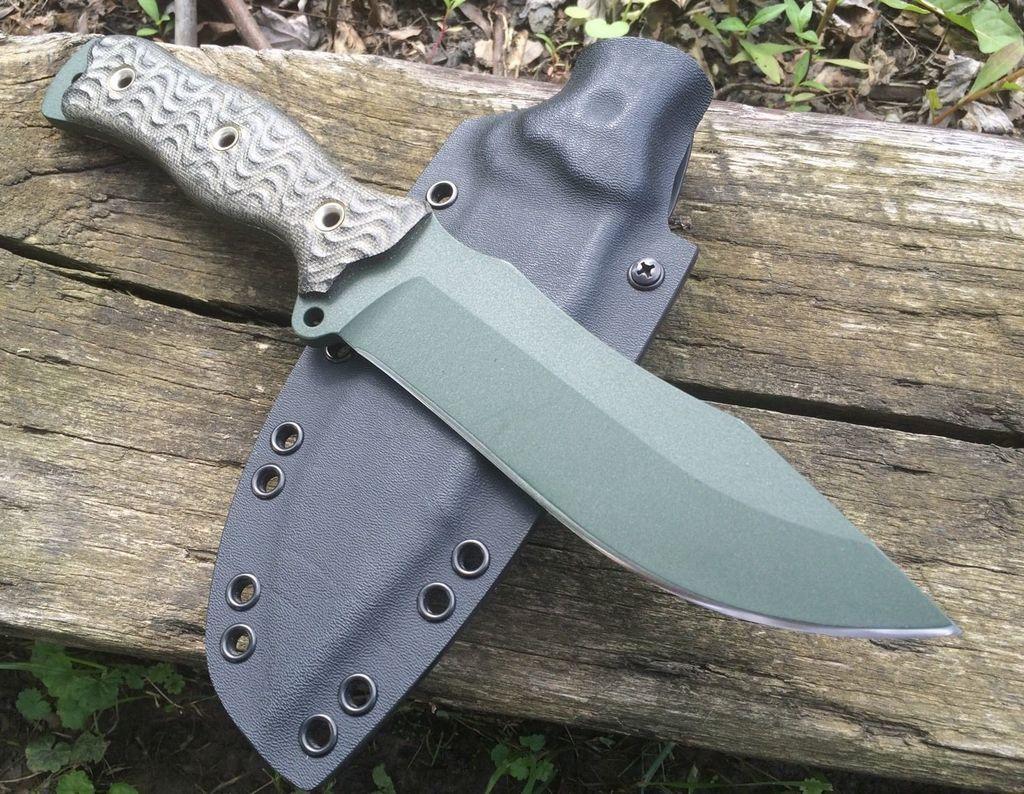How would you summarize this image in a sentence or two? In this image, we can see a knife and knife bag is placed on the wooden board. Here we can see few plants. 